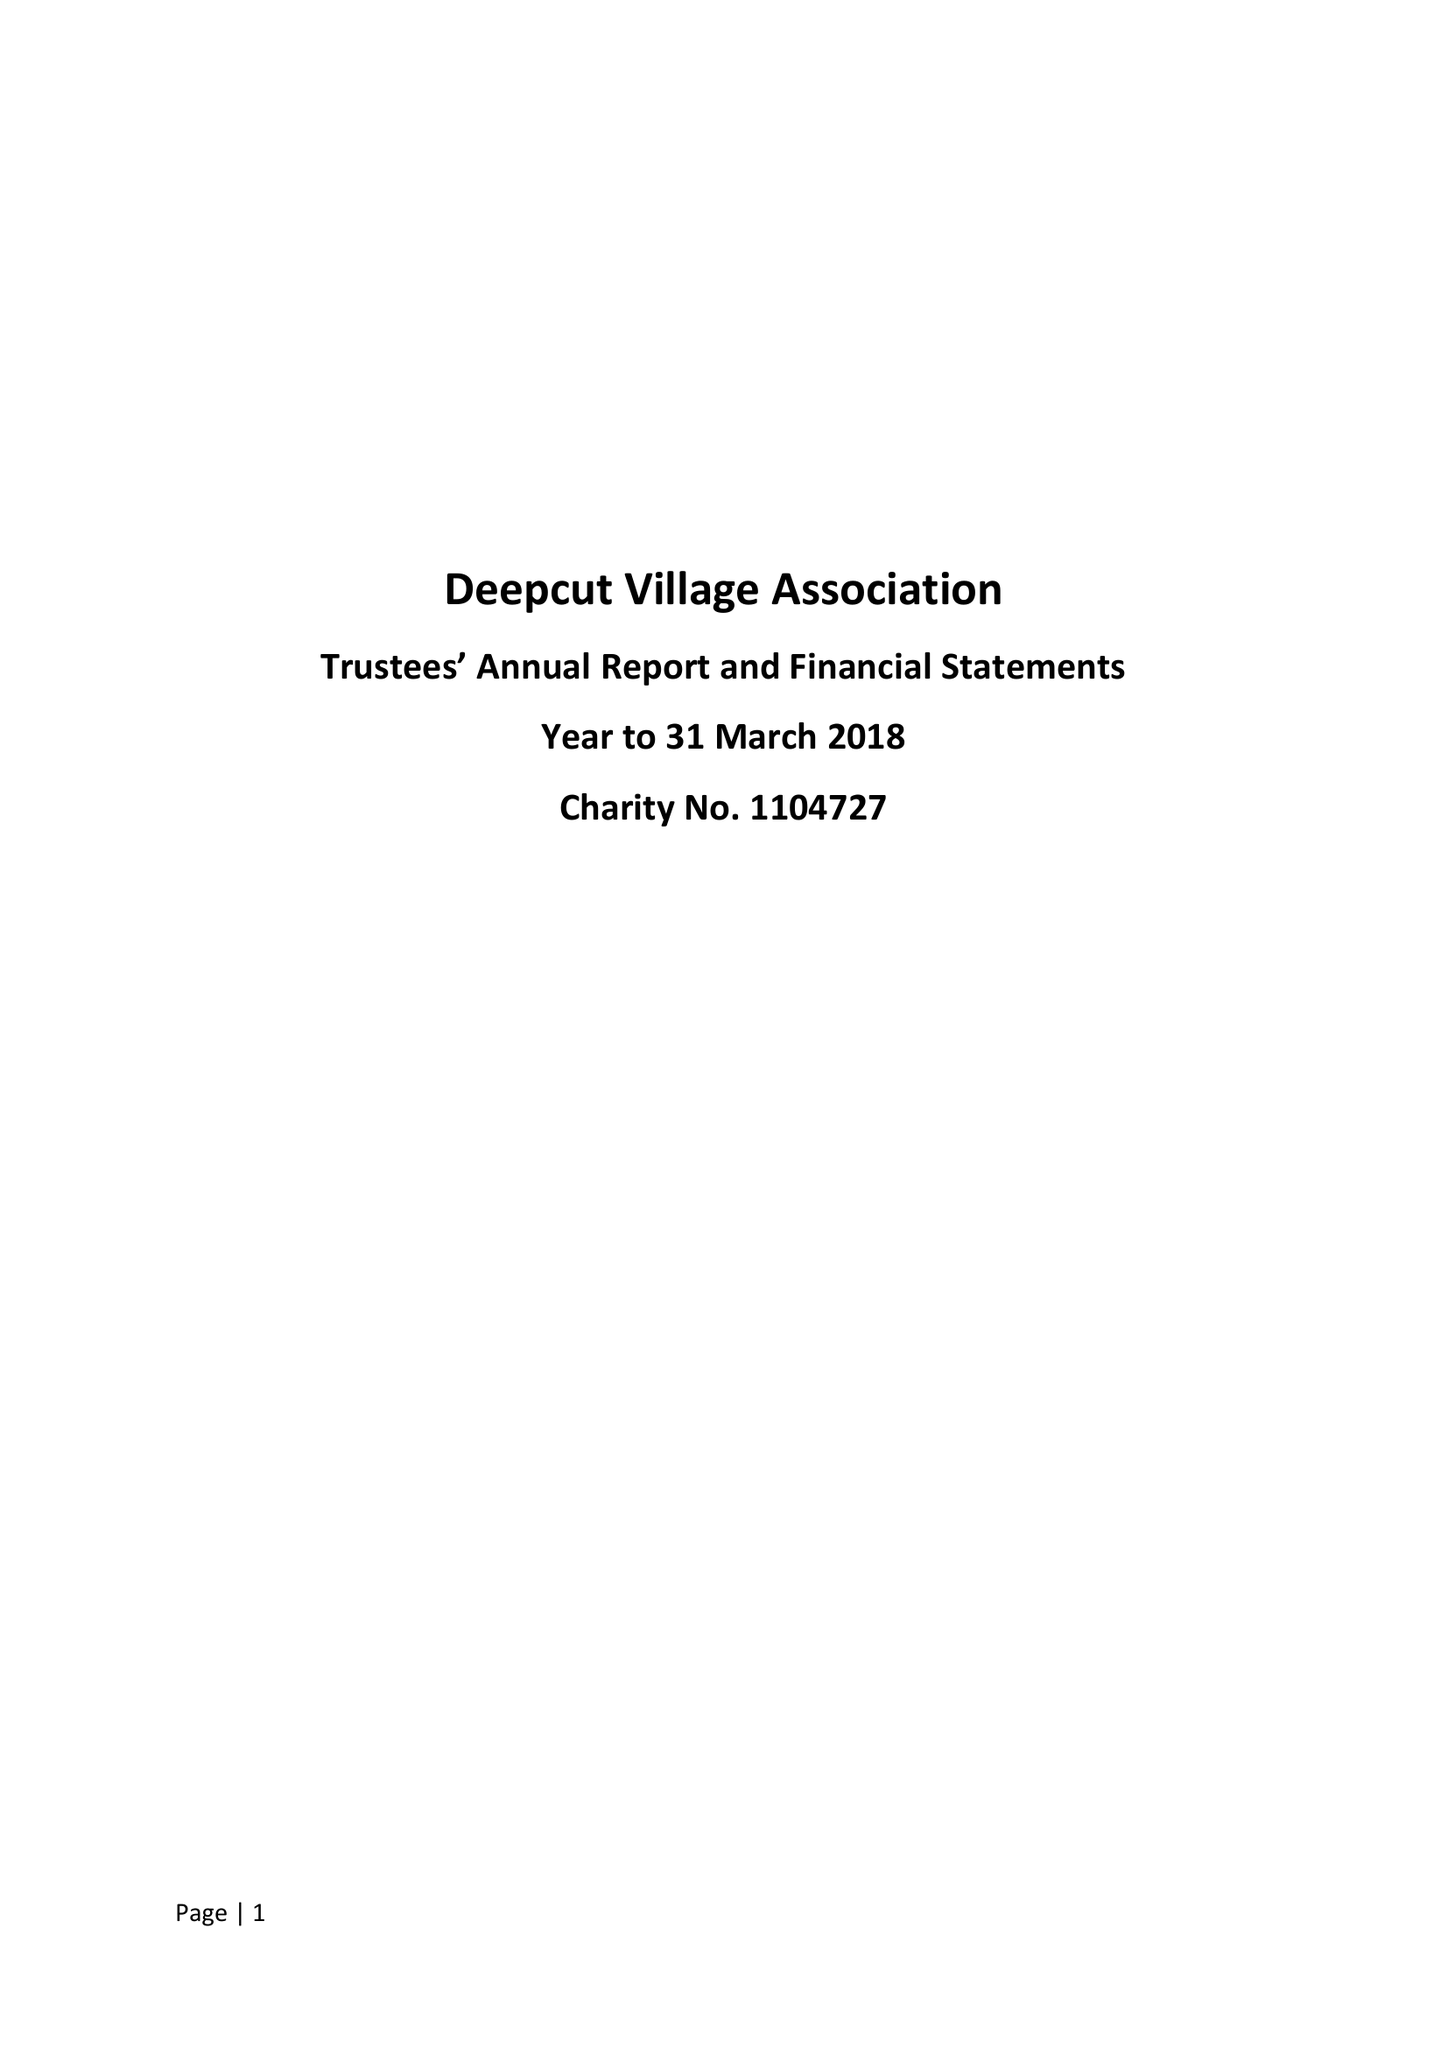What is the value for the income_annually_in_british_pounds?
Answer the question using a single word or phrase. 57336.00 